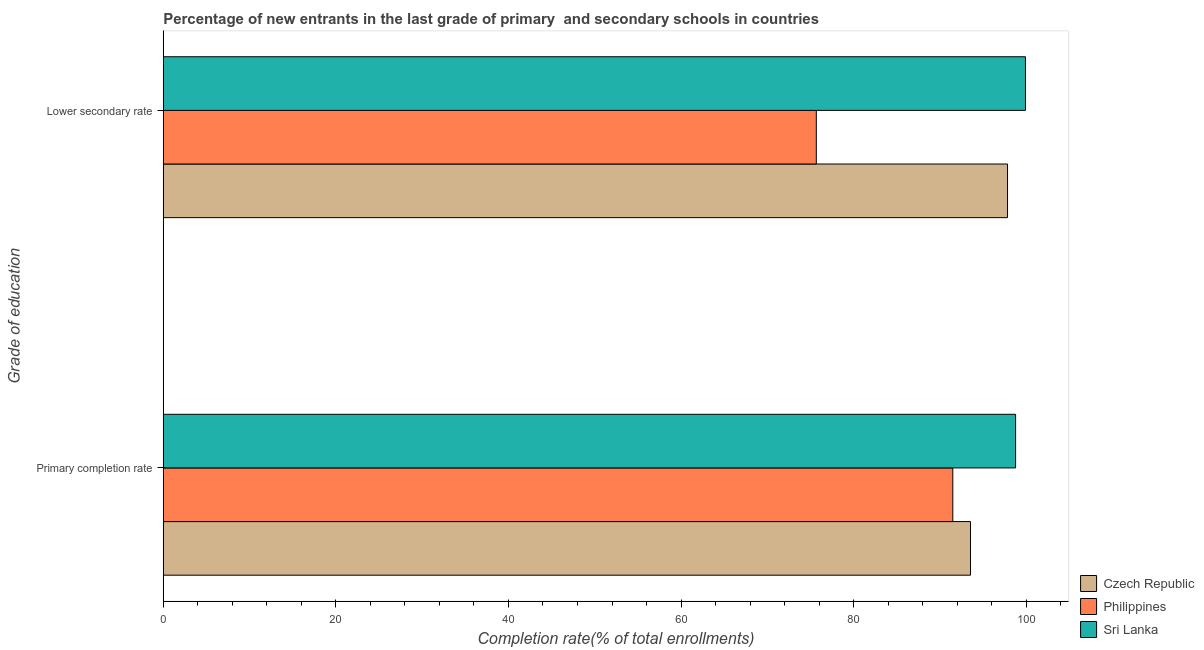What is the label of the 2nd group of bars from the top?
Your answer should be compact. Primary completion rate. What is the completion rate in secondary schools in Philippines?
Give a very brief answer. 75.68. Across all countries, what is the maximum completion rate in primary schools?
Offer a very short reply. 98.77. Across all countries, what is the minimum completion rate in primary schools?
Give a very brief answer. 91.49. In which country was the completion rate in secondary schools maximum?
Ensure brevity in your answer.  Sri Lanka. What is the total completion rate in primary schools in the graph?
Offer a terse response. 283.8. What is the difference between the completion rate in secondary schools in Philippines and that in Sri Lanka?
Keep it short and to the point. -24.24. What is the difference between the completion rate in primary schools in Czech Republic and the completion rate in secondary schools in Sri Lanka?
Your answer should be compact. -6.37. What is the average completion rate in primary schools per country?
Provide a succinct answer. 94.6. What is the difference between the completion rate in primary schools and completion rate in secondary schools in Philippines?
Give a very brief answer. 15.82. In how many countries, is the completion rate in secondary schools greater than 40 %?
Provide a short and direct response. 3. What is the ratio of the completion rate in secondary schools in Philippines to that in Czech Republic?
Your answer should be compact. 0.77. Is the completion rate in primary schools in Philippines less than that in Sri Lanka?
Keep it short and to the point. Yes. In how many countries, is the completion rate in primary schools greater than the average completion rate in primary schools taken over all countries?
Provide a short and direct response. 1. What does the 1st bar from the top in Primary completion rate represents?
Your response must be concise. Sri Lanka. Are all the bars in the graph horizontal?
Keep it short and to the point. Yes. What is the difference between two consecutive major ticks on the X-axis?
Keep it short and to the point. 20. Does the graph contain grids?
Your answer should be very brief. No. How many legend labels are there?
Offer a very short reply. 3. What is the title of the graph?
Provide a succinct answer. Percentage of new entrants in the last grade of primary  and secondary schools in countries. Does "Georgia" appear as one of the legend labels in the graph?
Provide a succinct answer. No. What is the label or title of the X-axis?
Make the answer very short. Completion rate(% of total enrollments). What is the label or title of the Y-axis?
Offer a terse response. Grade of education. What is the Completion rate(% of total enrollments) in Czech Republic in Primary completion rate?
Provide a short and direct response. 93.54. What is the Completion rate(% of total enrollments) of Philippines in Primary completion rate?
Make the answer very short. 91.49. What is the Completion rate(% of total enrollments) of Sri Lanka in Primary completion rate?
Offer a very short reply. 98.77. What is the Completion rate(% of total enrollments) of Czech Republic in Lower secondary rate?
Offer a terse response. 97.84. What is the Completion rate(% of total enrollments) of Philippines in Lower secondary rate?
Your response must be concise. 75.68. What is the Completion rate(% of total enrollments) in Sri Lanka in Lower secondary rate?
Keep it short and to the point. 99.91. Across all Grade of education, what is the maximum Completion rate(% of total enrollments) of Czech Republic?
Provide a short and direct response. 97.84. Across all Grade of education, what is the maximum Completion rate(% of total enrollments) of Philippines?
Your answer should be compact. 91.49. Across all Grade of education, what is the maximum Completion rate(% of total enrollments) of Sri Lanka?
Ensure brevity in your answer.  99.91. Across all Grade of education, what is the minimum Completion rate(% of total enrollments) in Czech Republic?
Provide a succinct answer. 93.54. Across all Grade of education, what is the minimum Completion rate(% of total enrollments) in Philippines?
Give a very brief answer. 75.68. Across all Grade of education, what is the minimum Completion rate(% of total enrollments) in Sri Lanka?
Offer a terse response. 98.77. What is the total Completion rate(% of total enrollments) in Czech Republic in the graph?
Give a very brief answer. 191.38. What is the total Completion rate(% of total enrollments) in Philippines in the graph?
Ensure brevity in your answer.  167.17. What is the total Completion rate(% of total enrollments) of Sri Lanka in the graph?
Ensure brevity in your answer.  198.68. What is the difference between the Completion rate(% of total enrollments) in Czech Republic in Primary completion rate and that in Lower secondary rate?
Provide a succinct answer. -4.29. What is the difference between the Completion rate(% of total enrollments) in Philippines in Primary completion rate and that in Lower secondary rate?
Offer a terse response. 15.82. What is the difference between the Completion rate(% of total enrollments) of Sri Lanka in Primary completion rate and that in Lower secondary rate?
Your answer should be very brief. -1.14. What is the difference between the Completion rate(% of total enrollments) of Czech Republic in Primary completion rate and the Completion rate(% of total enrollments) of Philippines in Lower secondary rate?
Provide a succinct answer. 17.86. What is the difference between the Completion rate(% of total enrollments) of Czech Republic in Primary completion rate and the Completion rate(% of total enrollments) of Sri Lanka in Lower secondary rate?
Your answer should be compact. -6.37. What is the difference between the Completion rate(% of total enrollments) of Philippines in Primary completion rate and the Completion rate(% of total enrollments) of Sri Lanka in Lower secondary rate?
Your response must be concise. -8.42. What is the average Completion rate(% of total enrollments) in Czech Republic per Grade of education?
Offer a terse response. 95.69. What is the average Completion rate(% of total enrollments) of Philippines per Grade of education?
Offer a very short reply. 83.58. What is the average Completion rate(% of total enrollments) in Sri Lanka per Grade of education?
Your response must be concise. 99.34. What is the difference between the Completion rate(% of total enrollments) in Czech Republic and Completion rate(% of total enrollments) in Philippines in Primary completion rate?
Your answer should be compact. 2.05. What is the difference between the Completion rate(% of total enrollments) in Czech Republic and Completion rate(% of total enrollments) in Sri Lanka in Primary completion rate?
Offer a very short reply. -5.23. What is the difference between the Completion rate(% of total enrollments) in Philippines and Completion rate(% of total enrollments) in Sri Lanka in Primary completion rate?
Give a very brief answer. -7.28. What is the difference between the Completion rate(% of total enrollments) of Czech Republic and Completion rate(% of total enrollments) of Philippines in Lower secondary rate?
Provide a short and direct response. 22.16. What is the difference between the Completion rate(% of total enrollments) of Czech Republic and Completion rate(% of total enrollments) of Sri Lanka in Lower secondary rate?
Your answer should be very brief. -2.08. What is the difference between the Completion rate(% of total enrollments) in Philippines and Completion rate(% of total enrollments) in Sri Lanka in Lower secondary rate?
Give a very brief answer. -24.24. What is the ratio of the Completion rate(% of total enrollments) in Czech Republic in Primary completion rate to that in Lower secondary rate?
Offer a terse response. 0.96. What is the ratio of the Completion rate(% of total enrollments) of Philippines in Primary completion rate to that in Lower secondary rate?
Your answer should be compact. 1.21. What is the difference between the highest and the second highest Completion rate(% of total enrollments) in Czech Republic?
Keep it short and to the point. 4.29. What is the difference between the highest and the second highest Completion rate(% of total enrollments) in Philippines?
Provide a short and direct response. 15.82. What is the difference between the highest and the second highest Completion rate(% of total enrollments) in Sri Lanka?
Provide a short and direct response. 1.14. What is the difference between the highest and the lowest Completion rate(% of total enrollments) of Czech Republic?
Your response must be concise. 4.29. What is the difference between the highest and the lowest Completion rate(% of total enrollments) in Philippines?
Offer a very short reply. 15.82. What is the difference between the highest and the lowest Completion rate(% of total enrollments) of Sri Lanka?
Offer a terse response. 1.14. 